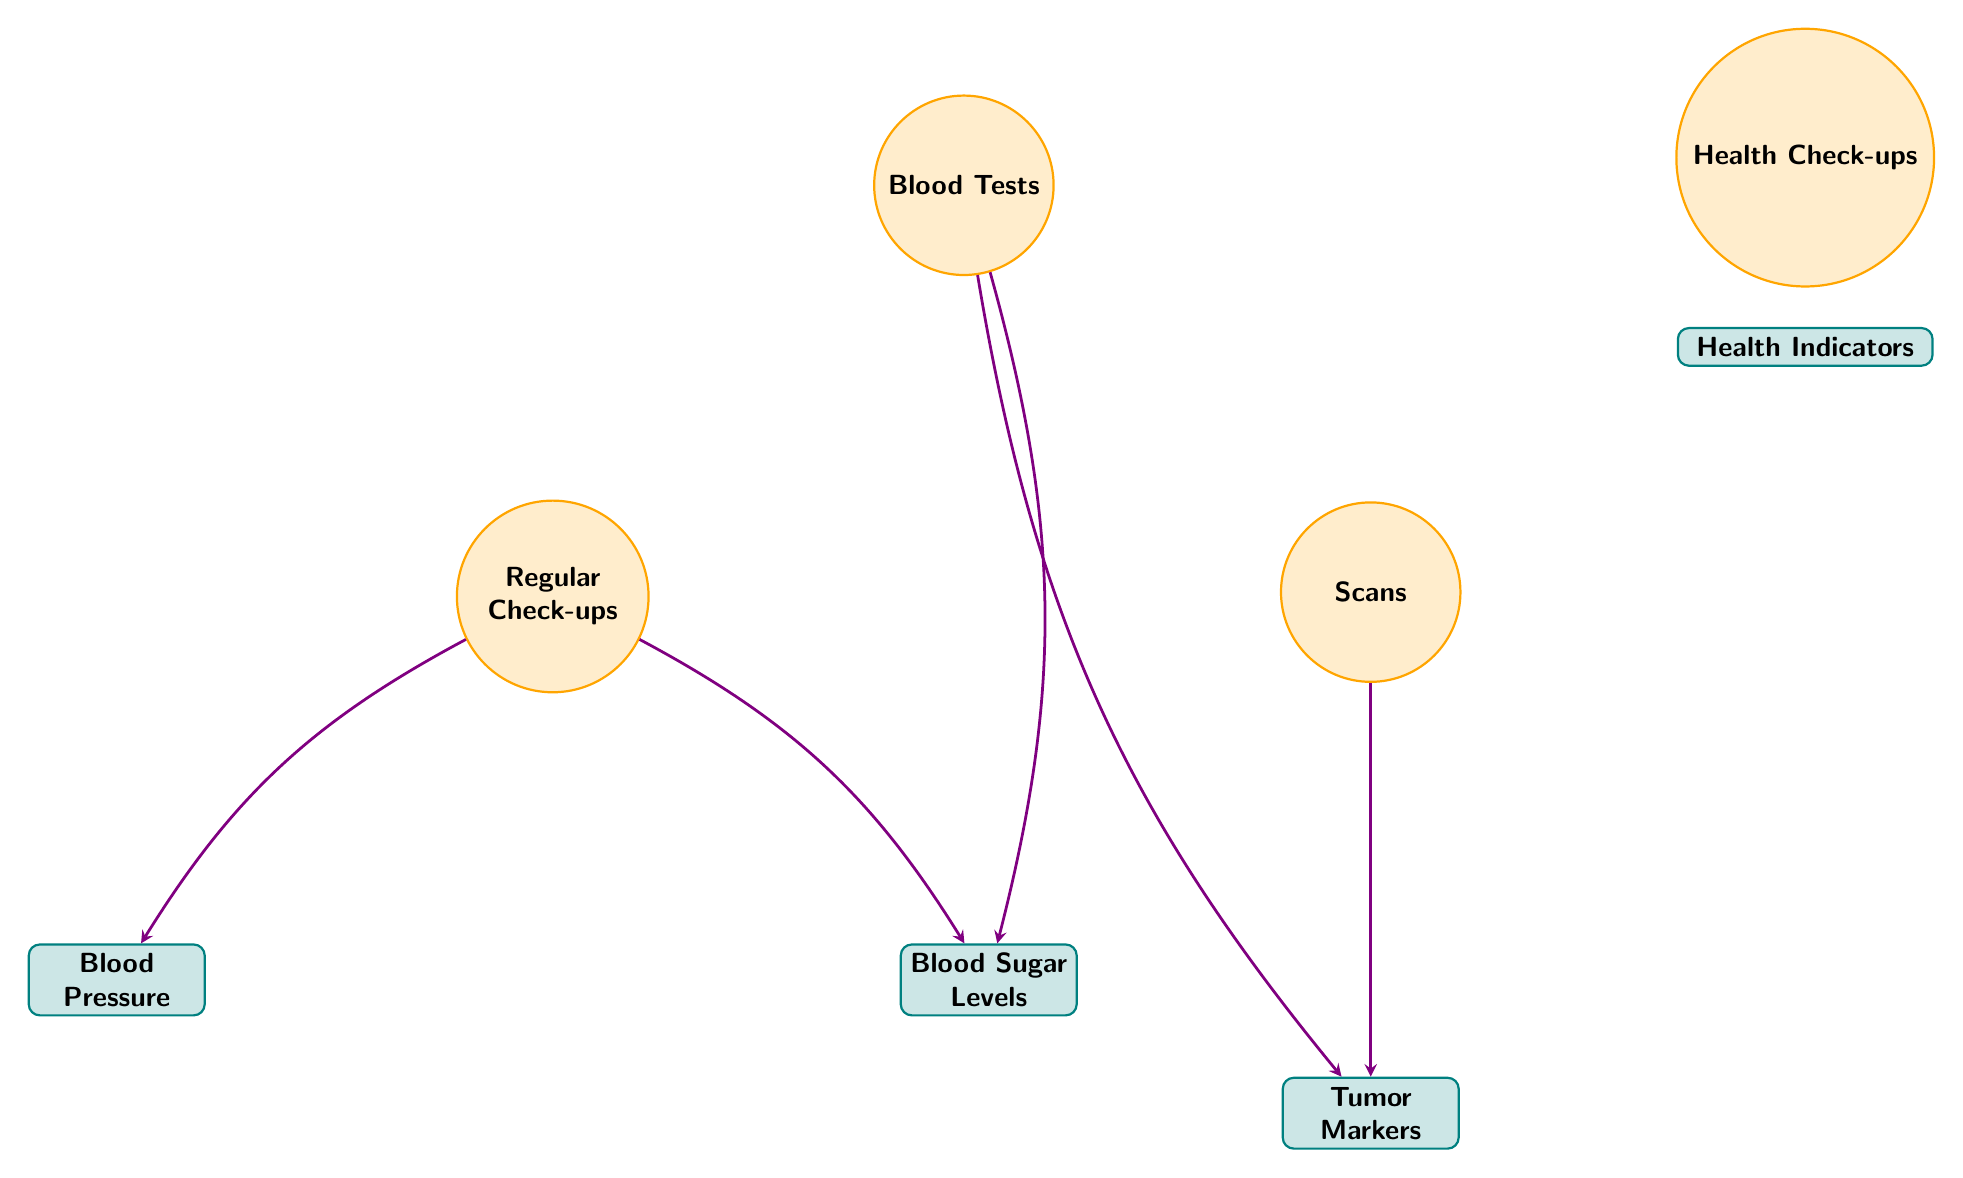What types of health check-ups are represented in the diagram? The diagram includes three types of health check-ups: Blood Tests, Scans, and Regular Check-ups. These are explicitly listed as nodes under the category "Health Check-ups."
Answer: Blood Tests, Scans, Regular Check-ups How many health indicators are depicted in the diagram? The diagram shows three health indicators: Blood Pressure, Tumor Markers, and Blood Sugar Levels. Counting these gives a total of three indicators represented as nodes.
Answer: 3 Which health check-up is connected to Blood Pressure? The diagram shows that Regular Check-ups are the health check-up connected to Blood Pressure, as indicated by the directed connection between the two nodes in the diagram.
Answer: Regular Check-ups What health indicator is connected to both Blood Tests and Regular Check-ups? The health indicator Blood Sugar Levels has connections from both Blood Tests and Regular Check-ups, as evidenced by the links drawn to this indicator from both relevant health check-up nodes.
Answer: Blood Sugar Levels Do Scans connect to any health indicators directly? The diagram indicates that Scans connect directly to one health indicator, which is Tumor Markers, as seen from the direct edge linking these two nodes.
Answer: Tumor Markers Which health check-up has connections to the highest number of health indicators? Blood Tests and Regular Check-ups are both connected to two health indicators each (Blood Sugar Levels and Tumor Markers for Blood Tests; Blood Pressure and Blood Sugar Levels for Regular Check-ups), but no single health check-up exceeds this number.
Answer: Blood Tests, Regular Check-ups Is there a health indicator that connects to multiple health check-ups? Yes, Blood Sugar Levels connects to both Blood Tests and Regular Check-ups, demonstrating that this indicator is closely monitored through multiple check-up types as shown by the respective edges in the diagram.
Answer: Blood Sugar Levels How many connections link health check-ups to health indicators in total? The diagram contains five directed connections in total, linking various health check-ups to health indicators, which can be counted by tallying the edges represented in the visual.
Answer: 5 Which health check-up is not connected to Tumor Markers? The health check-up that is not connected to Tumor Markers is Blood Tests, as this connection is specifically linked to Scans. The diagram shows that only Scans has a direct connection to that indicator.
Answer: Blood Tests 